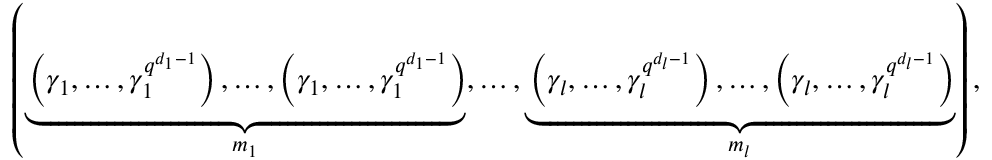Convert formula to latex. <formula><loc_0><loc_0><loc_500><loc_500>\left ( \underbrace { \left ( \gamma _ { 1 } , \dots , \gamma _ { 1 } ^ { q ^ { d _ { 1 } - 1 } } \right ) , \dots , \left ( \gamma _ { 1 } , \dots , \gamma _ { 1 } ^ { q ^ { d _ { 1 } - 1 } } \right ) } _ { m _ { 1 } } , \dots , \underbrace { \left ( \gamma _ { l } , \dots , \gamma _ { l } ^ { q ^ { d _ { l } - 1 } } \right ) , \dots , \left ( \gamma _ { l } , \dots , \gamma _ { l } ^ { q ^ { d _ { l } - 1 } } \right ) } _ { m _ { l } } \right ) ,</formula> 